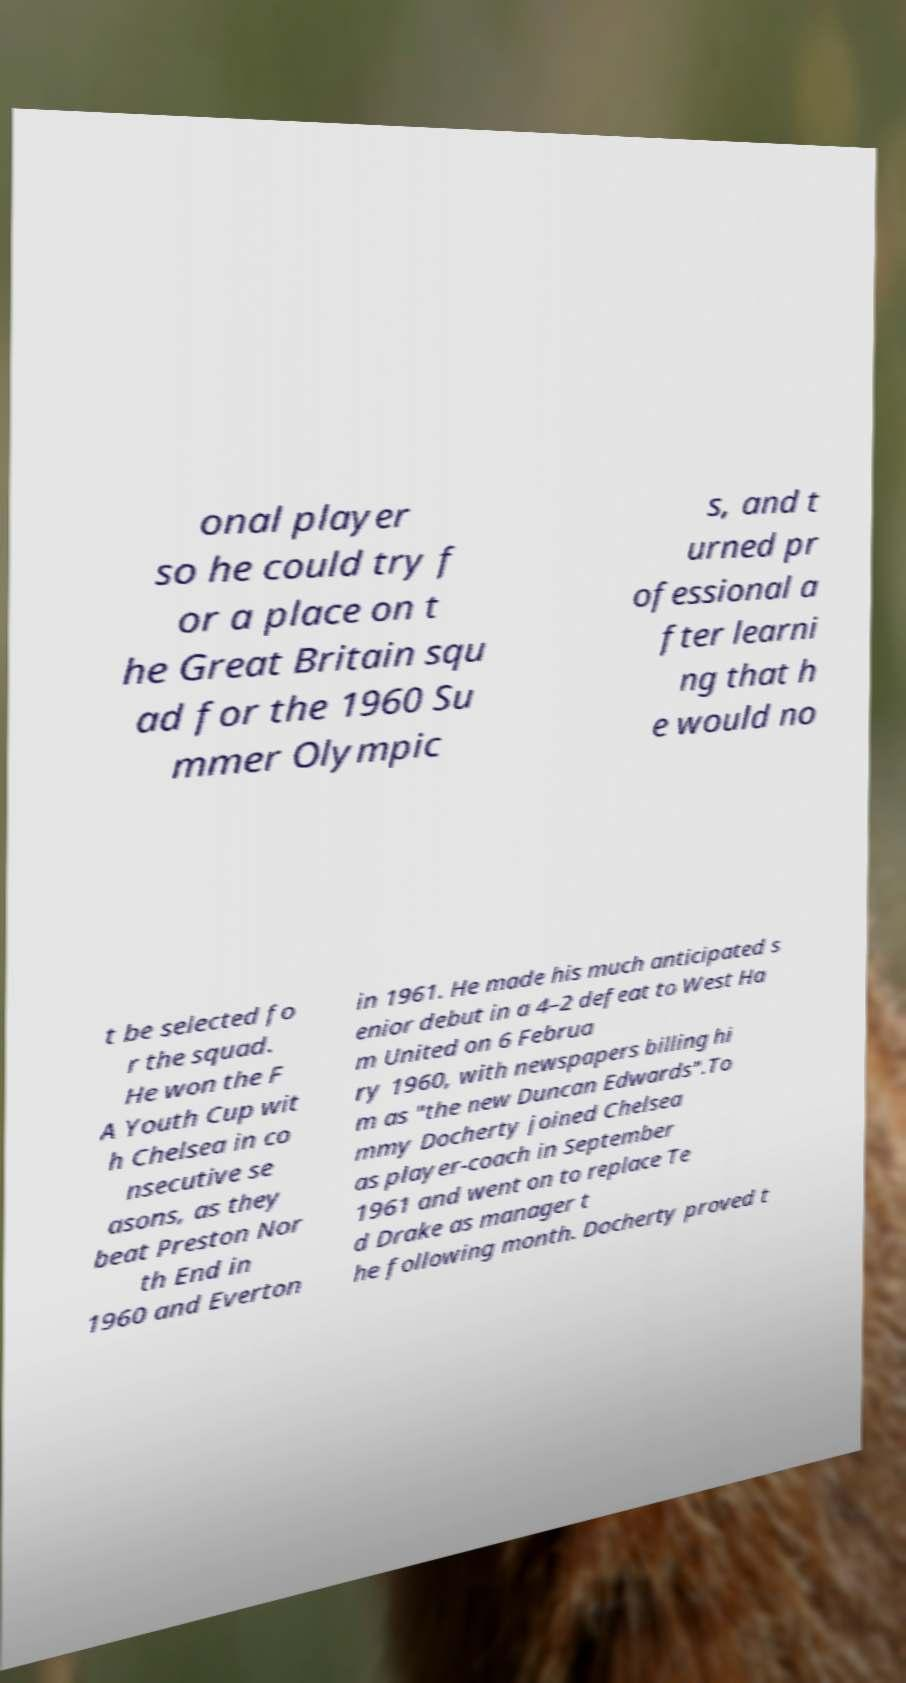Can you accurately transcribe the text from the provided image for me? onal player so he could try f or a place on t he Great Britain squ ad for the 1960 Su mmer Olympic s, and t urned pr ofessional a fter learni ng that h e would no t be selected fo r the squad. He won the F A Youth Cup wit h Chelsea in co nsecutive se asons, as they beat Preston Nor th End in 1960 and Everton in 1961. He made his much anticipated s enior debut in a 4–2 defeat to West Ha m United on 6 Februa ry 1960, with newspapers billing hi m as "the new Duncan Edwards".To mmy Docherty joined Chelsea as player-coach in September 1961 and went on to replace Te d Drake as manager t he following month. Docherty proved t 